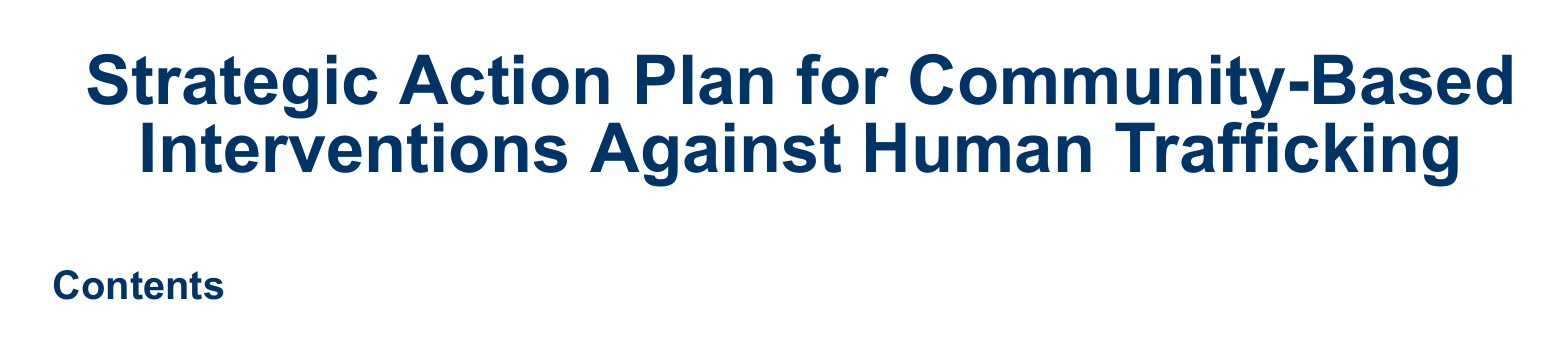what is the title of the document? The title is clearly stated at the beginning of the document, which is focused on strategic actions against human trafficking.
Answer: Strategic Action Plan for Community-Based Interventions Against Human Trafficking how many columns are used in the table of contents? The table of contents is rendered in two columns as indicated by the use of the multicols package.
Answer: 2 what is the font used in the document? The document specifies the main font to be used throughout, which is essential for maintaining a consistent style.
Answer: Arial what color is used for the section headings? The color for the section headings is defined at the start of the document, highlighting its importance in visual structure.
Answer: RGB(0,51,102) what is the significance of the margin setting in the document? The margin setting is crucial for ensuring that the content fits well within the printed page layout.
Answer: 1 cm what section formatting style is used for subsections in the document? The subsection formatting includes specific text styling and color, which enhances the document's readability and organization.
Answer: normal size and bold how is the document's content structured? The document's structure is indicated by the sectioning commands, showcasing the hierarchical organization of topics covered in the action plan.
Answer: Sections and subsections what should be the depth of section numbering in the document? The document specifies how deep the numbering should go, which is crucial for organization and clarity in longer documents.
Answer: 2 